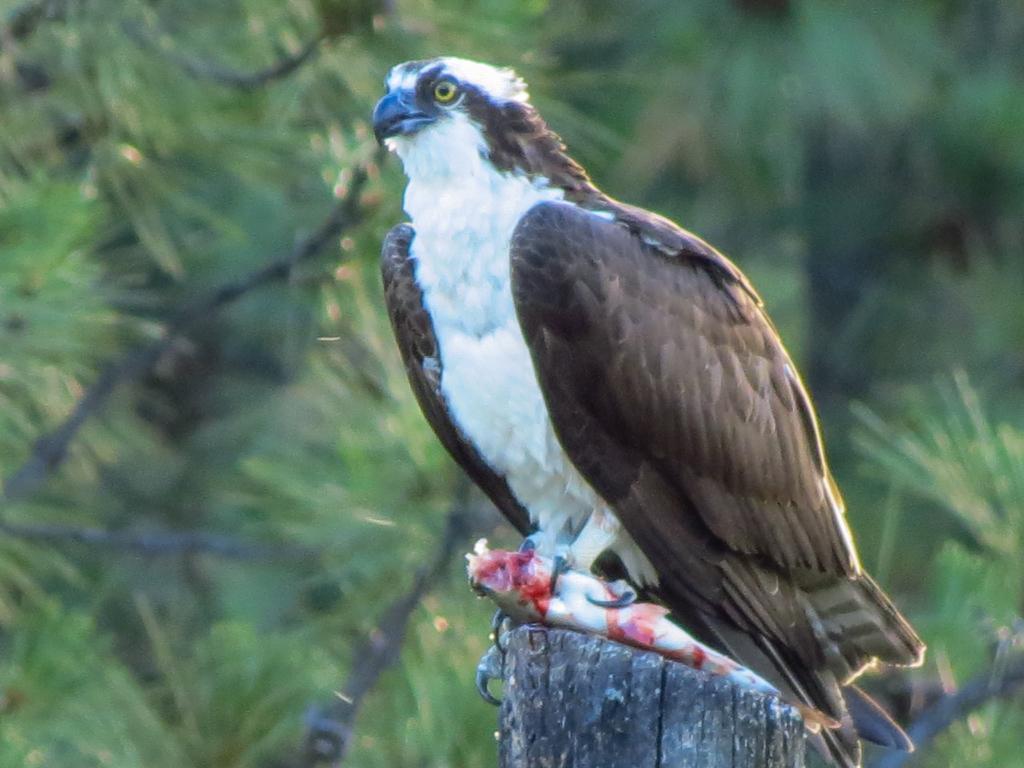How would you summarize this image in a sentence or two? This image consists of an eagle sitting on the wooden stick. In its claws there is a fish. In the background, there are trees. 